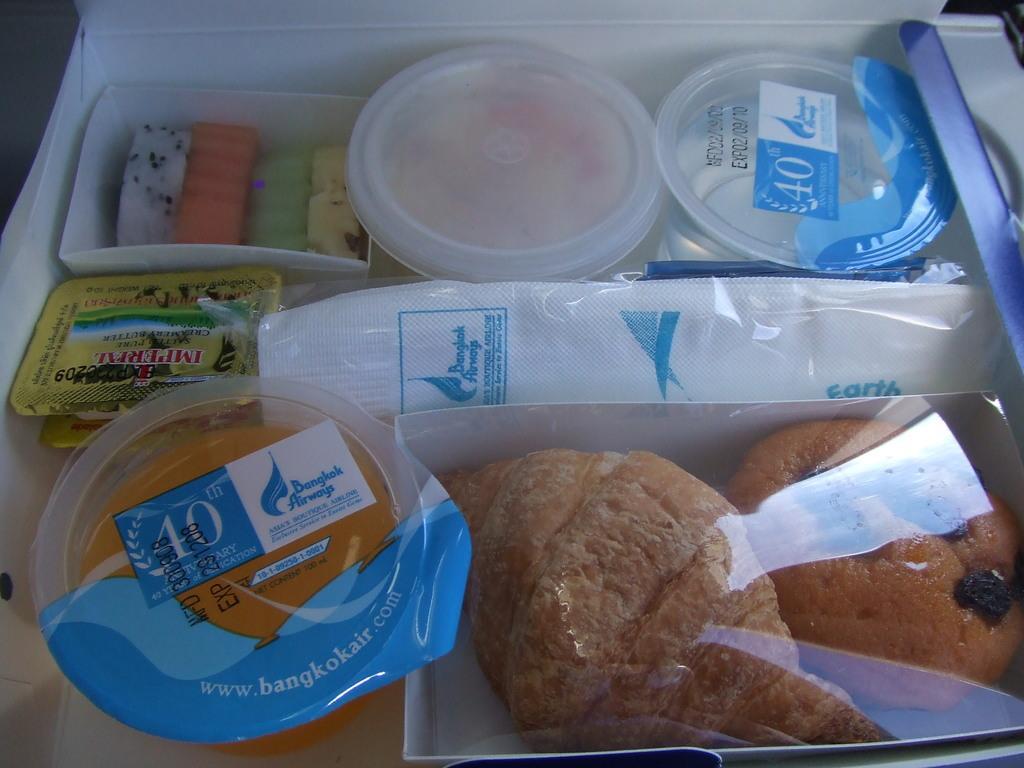How would you summarize this image in a sentence or two? In this image we can see some food, juice in glasses and some tissue papers in a box which is placed on the surface. 